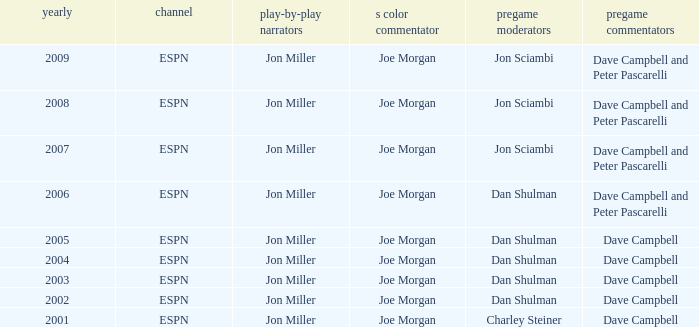Who is the pregame host when the pregame analysts is  Dave Campbell and the year is 2001? Charley Steiner. 